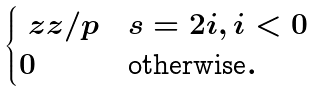Convert formula to latex. <formula><loc_0><loc_0><loc_500><loc_500>\begin{cases} \ z z / p & s = 2 i , i < 0 \\ 0 & \text {otherwise} . \end{cases}</formula> 